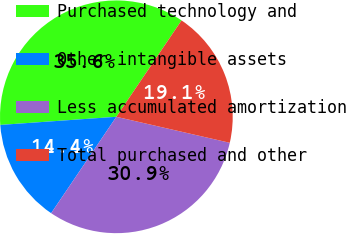<chart> <loc_0><loc_0><loc_500><loc_500><pie_chart><fcel>Purchased technology and<fcel>Other intangible assets<fcel>Less accumulated amortization<fcel>Total purchased and other<nl><fcel>35.58%<fcel>14.42%<fcel>30.88%<fcel>19.12%<nl></chart> 